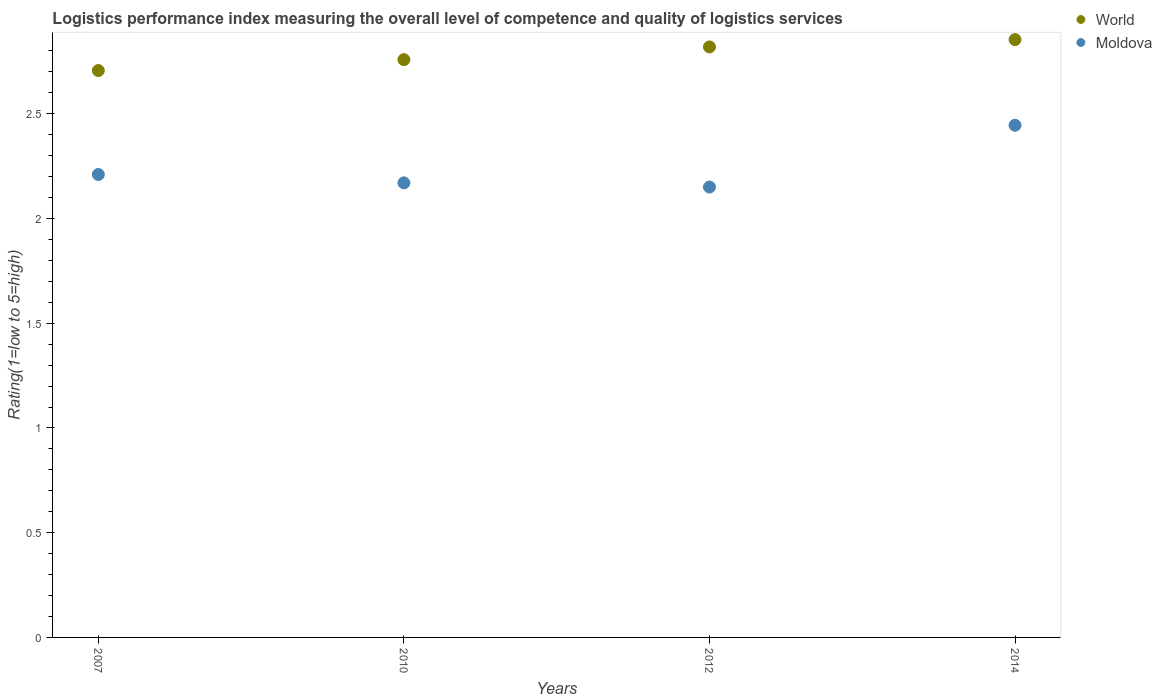How many different coloured dotlines are there?
Keep it short and to the point. 2. Is the number of dotlines equal to the number of legend labels?
Your response must be concise. Yes. What is the Logistic performance index in Moldova in 2010?
Provide a short and direct response. 2.17. Across all years, what is the maximum Logistic performance index in World?
Provide a short and direct response. 2.85. Across all years, what is the minimum Logistic performance index in World?
Your response must be concise. 2.71. In which year was the Logistic performance index in Moldova minimum?
Offer a very short reply. 2012. What is the total Logistic performance index in Moldova in the graph?
Keep it short and to the point. 8.97. What is the difference between the Logistic performance index in World in 2010 and that in 2014?
Provide a succinct answer. -0.1. What is the difference between the Logistic performance index in World in 2012 and the Logistic performance index in Moldova in 2010?
Your response must be concise. 0.65. What is the average Logistic performance index in Moldova per year?
Offer a terse response. 2.24. In the year 2010, what is the difference between the Logistic performance index in World and Logistic performance index in Moldova?
Provide a short and direct response. 0.59. In how many years, is the Logistic performance index in World greater than 2.6?
Keep it short and to the point. 4. What is the ratio of the Logistic performance index in World in 2010 to that in 2012?
Provide a succinct answer. 0.98. Is the difference between the Logistic performance index in World in 2010 and 2012 greater than the difference between the Logistic performance index in Moldova in 2010 and 2012?
Provide a short and direct response. No. What is the difference between the highest and the second highest Logistic performance index in Moldova?
Ensure brevity in your answer.  0.23. What is the difference between the highest and the lowest Logistic performance index in World?
Make the answer very short. 0.15. Is the Logistic performance index in Moldova strictly greater than the Logistic performance index in World over the years?
Provide a short and direct response. No. How many dotlines are there?
Provide a succinct answer. 2. What is the difference between two consecutive major ticks on the Y-axis?
Give a very brief answer. 0.5. Are the values on the major ticks of Y-axis written in scientific E-notation?
Keep it short and to the point. No. Does the graph contain any zero values?
Provide a short and direct response. No. Does the graph contain grids?
Make the answer very short. No. Where does the legend appear in the graph?
Keep it short and to the point. Top right. How many legend labels are there?
Ensure brevity in your answer.  2. How are the legend labels stacked?
Make the answer very short. Vertical. What is the title of the graph?
Your response must be concise. Logistics performance index measuring the overall level of competence and quality of logistics services. What is the label or title of the Y-axis?
Your answer should be compact. Rating(1=low to 5=high). What is the Rating(1=low to 5=high) in World in 2007?
Provide a short and direct response. 2.71. What is the Rating(1=low to 5=high) of Moldova in 2007?
Keep it short and to the point. 2.21. What is the Rating(1=low to 5=high) in World in 2010?
Provide a short and direct response. 2.76. What is the Rating(1=low to 5=high) of Moldova in 2010?
Your answer should be compact. 2.17. What is the Rating(1=low to 5=high) of World in 2012?
Ensure brevity in your answer.  2.82. What is the Rating(1=low to 5=high) of Moldova in 2012?
Make the answer very short. 2.15. What is the Rating(1=low to 5=high) of World in 2014?
Give a very brief answer. 2.85. What is the Rating(1=low to 5=high) in Moldova in 2014?
Give a very brief answer. 2.44. Across all years, what is the maximum Rating(1=low to 5=high) in World?
Your answer should be compact. 2.85. Across all years, what is the maximum Rating(1=low to 5=high) of Moldova?
Your answer should be very brief. 2.44. Across all years, what is the minimum Rating(1=low to 5=high) in World?
Your response must be concise. 2.71. Across all years, what is the minimum Rating(1=low to 5=high) in Moldova?
Your response must be concise. 2.15. What is the total Rating(1=low to 5=high) in World in the graph?
Provide a succinct answer. 11.14. What is the total Rating(1=low to 5=high) in Moldova in the graph?
Provide a succinct answer. 8.97. What is the difference between the Rating(1=low to 5=high) of World in 2007 and that in 2010?
Give a very brief answer. -0.05. What is the difference between the Rating(1=low to 5=high) in Moldova in 2007 and that in 2010?
Ensure brevity in your answer.  0.04. What is the difference between the Rating(1=low to 5=high) of World in 2007 and that in 2012?
Your answer should be compact. -0.11. What is the difference between the Rating(1=low to 5=high) in Moldova in 2007 and that in 2012?
Offer a terse response. 0.06. What is the difference between the Rating(1=low to 5=high) in World in 2007 and that in 2014?
Make the answer very short. -0.15. What is the difference between the Rating(1=low to 5=high) of Moldova in 2007 and that in 2014?
Your response must be concise. -0.23. What is the difference between the Rating(1=low to 5=high) in World in 2010 and that in 2012?
Your answer should be compact. -0.06. What is the difference between the Rating(1=low to 5=high) in World in 2010 and that in 2014?
Give a very brief answer. -0.1. What is the difference between the Rating(1=low to 5=high) of Moldova in 2010 and that in 2014?
Offer a very short reply. -0.28. What is the difference between the Rating(1=low to 5=high) in World in 2012 and that in 2014?
Provide a succinct answer. -0.03. What is the difference between the Rating(1=low to 5=high) of Moldova in 2012 and that in 2014?
Your response must be concise. -0.29. What is the difference between the Rating(1=low to 5=high) of World in 2007 and the Rating(1=low to 5=high) of Moldova in 2010?
Provide a succinct answer. 0.54. What is the difference between the Rating(1=low to 5=high) of World in 2007 and the Rating(1=low to 5=high) of Moldova in 2012?
Offer a terse response. 0.56. What is the difference between the Rating(1=low to 5=high) of World in 2007 and the Rating(1=low to 5=high) of Moldova in 2014?
Provide a succinct answer. 0.26. What is the difference between the Rating(1=low to 5=high) of World in 2010 and the Rating(1=low to 5=high) of Moldova in 2012?
Provide a succinct answer. 0.61. What is the difference between the Rating(1=low to 5=high) in World in 2010 and the Rating(1=low to 5=high) in Moldova in 2014?
Your response must be concise. 0.31. What is the difference between the Rating(1=low to 5=high) of World in 2012 and the Rating(1=low to 5=high) of Moldova in 2014?
Offer a very short reply. 0.37. What is the average Rating(1=low to 5=high) in World per year?
Your response must be concise. 2.78. What is the average Rating(1=low to 5=high) of Moldova per year?
Give a very brief answer. 2.24. In the year 2007, what is the difference between the Rating(1=low to 5=high) in World and Rating(1=low to 5=high) in Moldova?
Your response must be concise. 0.5. In the year 2010, what is the difference between the Rating(1=low to 5=high) in World and Rating(1=low to 5=high) in Moldova?
Give a very brief answer. 0.59. In the year 2012, what is the difference between the Rating(1=low to 5=high) in World and Rating(1=low to 5=high) in Moldova?
Offer a very short reply. 0.67. In the year 2014, what is the difference between the Rating(1=low to 5=high) of World and Rating(1=low to 5=high) of Moldova?
Keep it short and to the point. 0.41. What is the ratio of the Rating(1=low to 5=high) in World in 2007 to that in 2010?
Ensure brevity in your answer.  0.98. What is the ratio of the Rating(1=low to 5=high) of Moldova in 2007 to that in 2010?
Your answer should be compact. 1.02. What is the ratio of the Rating(1=low to 5=high) of Moldova in 2007 to that in 2012?
Make the answer very short. 1.03. What is the ratio of the Rating(1=low to 5=high) in World in 2007 to that in 2014?
Make the answer very short. 0.95. What is the ratio of the Rating(1=low to 5=high) in Moldova in 2007 to that in 2014?
Provide a short and direct response. 0.9. What is the ratio of the Rating(1=low to 5=high) of World in 2010 to that in 2012?
Ensure brevity in your answer.  0.98. What is the ratio of the Rating(1=low to 5=high) of Moldova in 2010 to that in 2012?
Provide a short and direct response. 1.01. What is the ratio of the Rating(1=low to 5=high) of World in 2010 to that in 2014?
Offer a very short reply. 0.97. What is the ratio of the Rating(1=low to 5=high) of Moldova in 2010 to that in 2014?
Your response must be concise. 0.89. What is the ratio of the Rating(1=low to 5=high) of World in 2012 to that in 2014?
Keep it short and to the point. 0.99. What is the ratio of the Rating(1=low to 5=high) of Moldova in 2012 to that in 2014?
Your answer should be compact. 0.88. What is the difference between the highest and the second highest Rating(1=low to 5=high) in World?
Offer a very short reply. 0.03. What is the difference between the highest and the second highest Rating(1=low to 5=high) in Moldova?
Offer a very short reply. 0.23. What is the difference between the highest and the lowest Rating(1=low to 5=high) of World?
Provide a short and direct response. 0.15. What is the difference between the highest and the lowest Rating(1=low to 5=high) in Moldova?
Offer a very short reply. 0.29. 